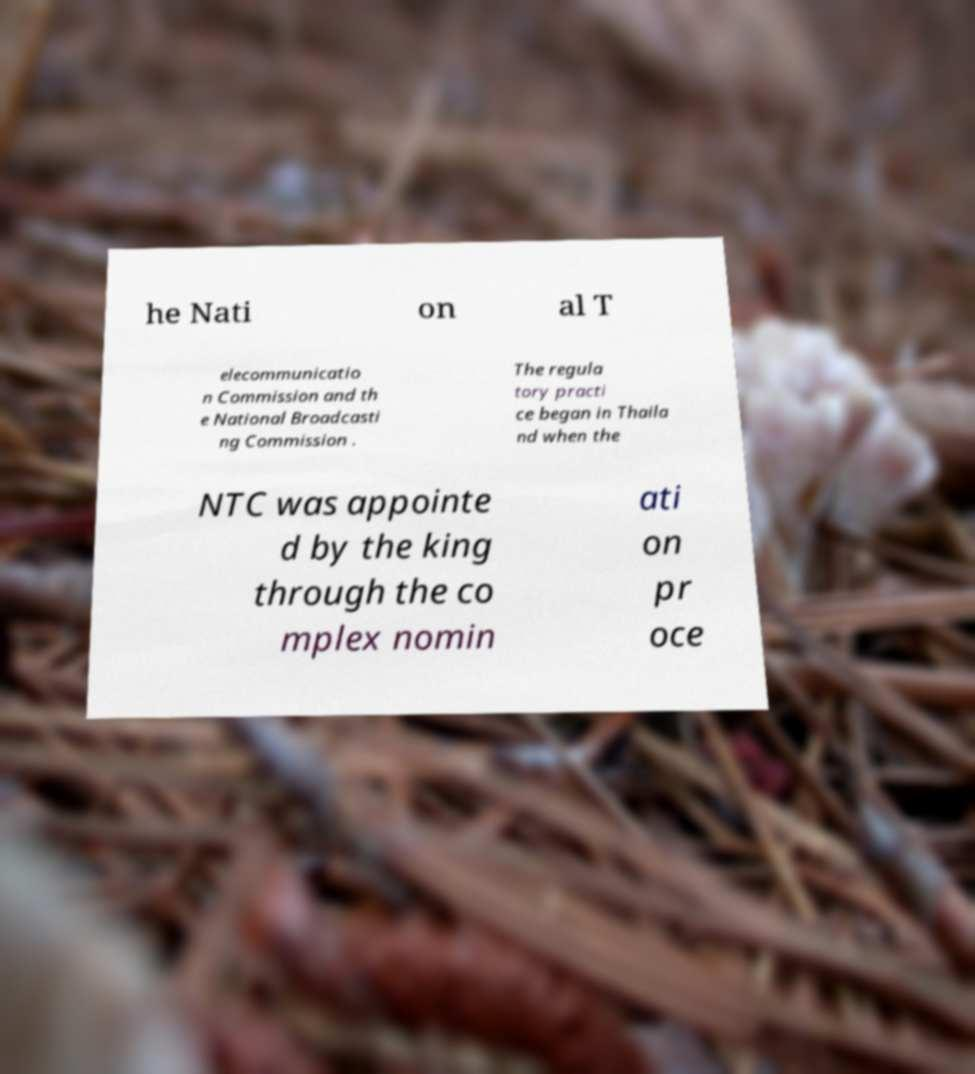Could you assist in decoding the text presented in this image and type it out clearly? he Nati on al T elecommunicatio n Commission and th e National Broadcasti ng Commission . The regula tory practi ce began in Thaila nd when the NTC was appointe d by the king through the co mplex nomin ati on pr oce 